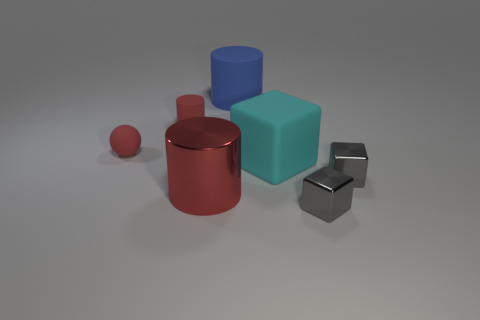Do the small sphere and the large shiny cylinder have the same color?
Your answer should be very brief. Yes. Are there any other things that have the same shape as the cyan matte thing?
Your response must be concise. Yes. Is there a large object that has the same color as the metallic cylinder?
Offer a terse response. No. Are the gray object that is in front of the big red metallic object and the red cylinder that is behind the big red object made of the same material?
Provide a succinct answer. No. What color is the rubber cube?
Your response must be concise. Cyan. What is the size of the red rubber object to the right of the small rubber thing on the left side of the small red rubber thing that is on the right side of the ball?
Your answer should be very brief. Small. What number of other things are there of the same size as the red sphere?
Give a very brief answer. 3. What number of objects have the same material as the blue cylinder?
Provide a succinct answer. 3. There is a big matte thing right of the big blue cylinder; what is its shape?
Your answer should be very brief. Cube. Does the large cyan cube have the same material as the red cylinder in front of the red rubber cylinder?
Offer a very short reply. No. 